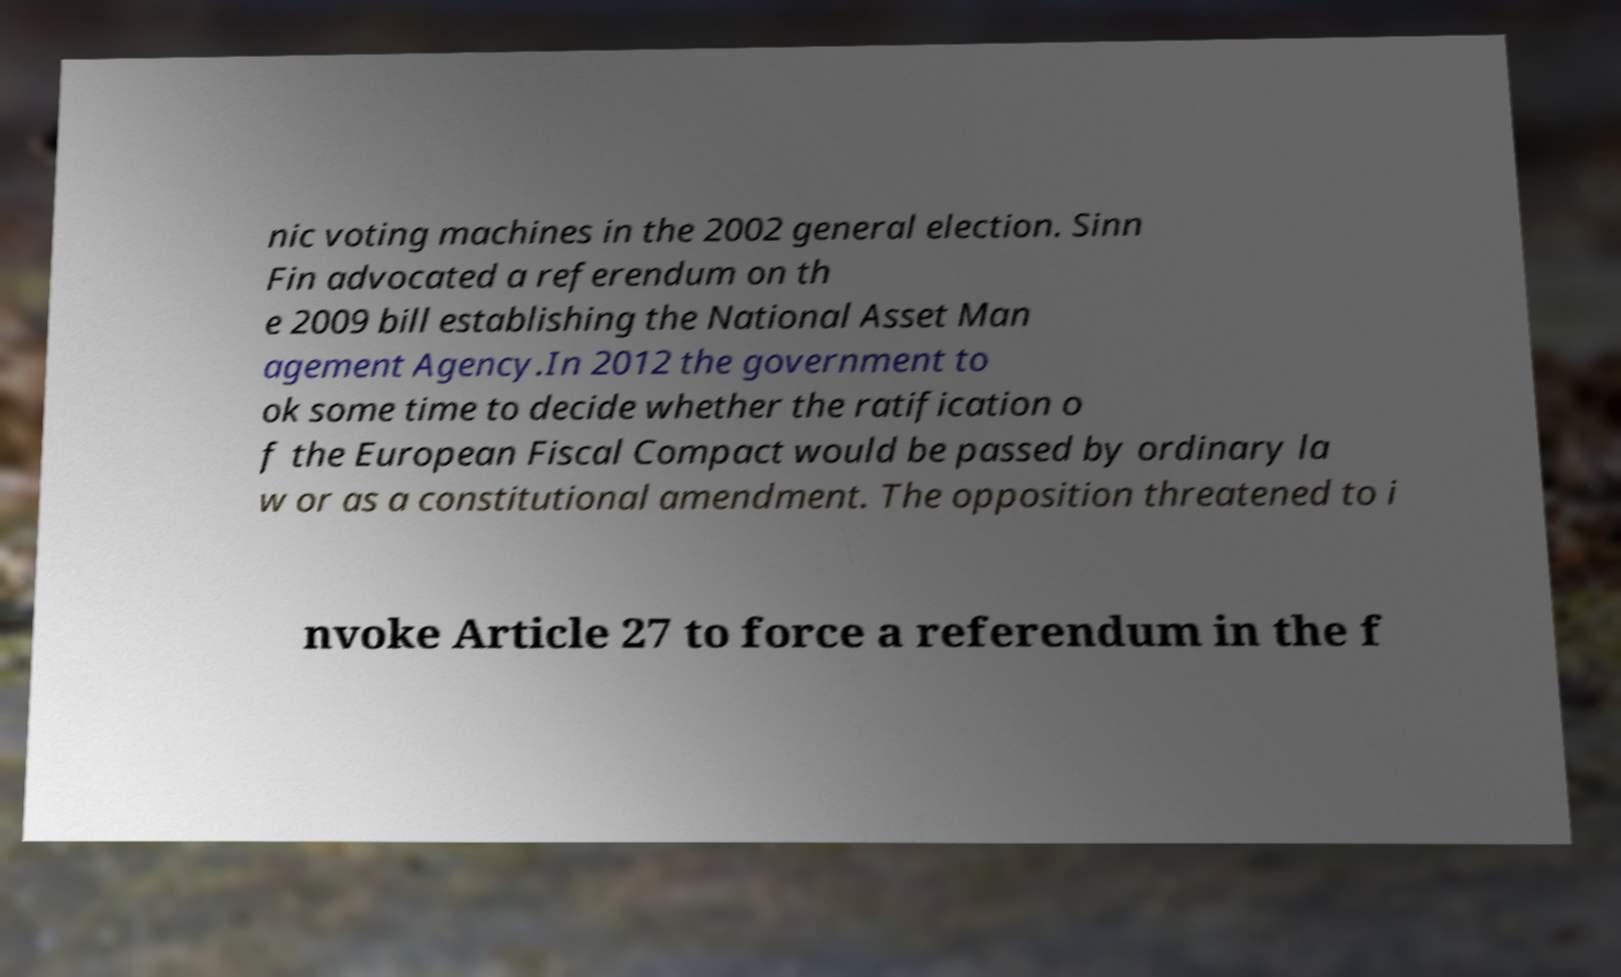There's text embedded in this image that I need extracted. Can you transcribe it verbatim? nic voting machines in the 2002 general election. Sinn Fin advocated a referendum on th e 2009 bill establishing the National Asset Man agement Agency.In 2012 the government to ok some time to decide whether the ratification o f the European Fiscal Compact would be passed by ordinary la w or as a constitutional amendment. The opposition threatened to i nvoke Article 27 to force a referendum in the f 